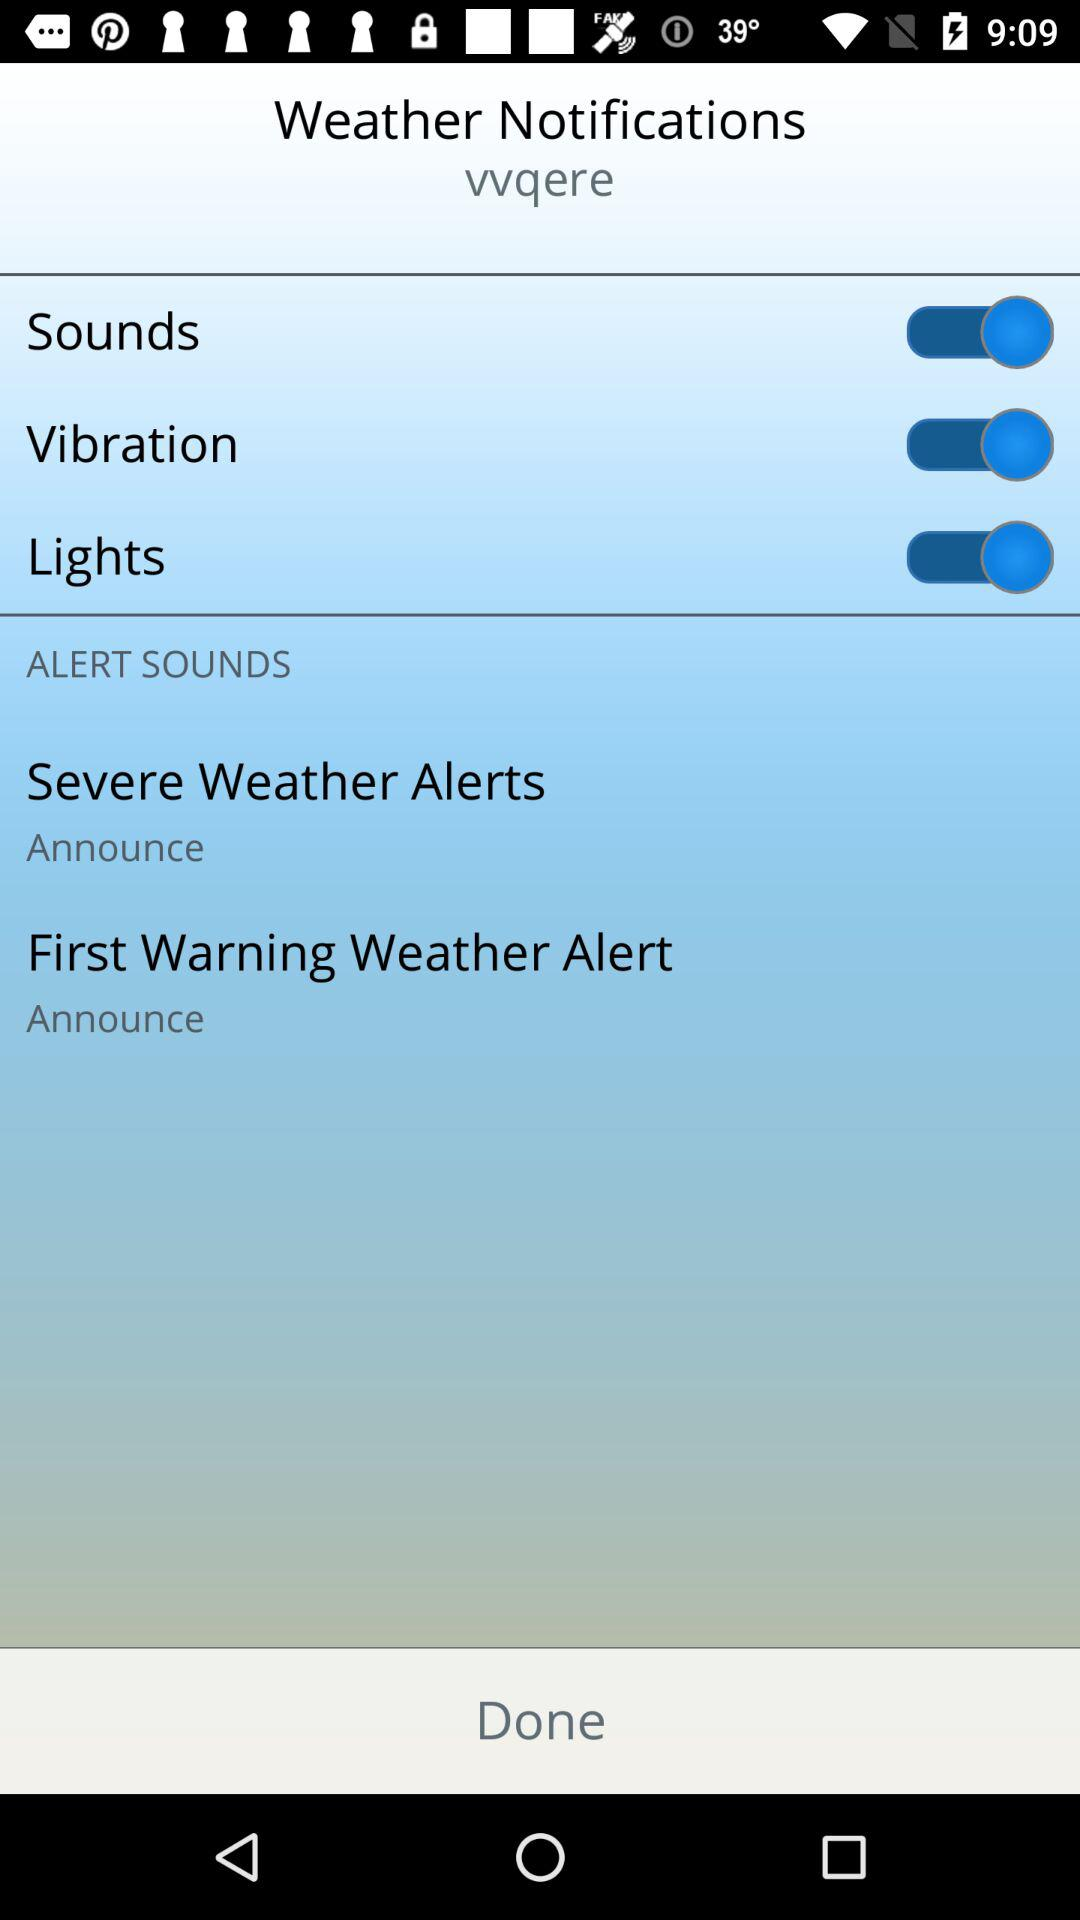How many more alerts are there for severe weather than for first warning weather?
Answer the question using a single word or phrase. 1 